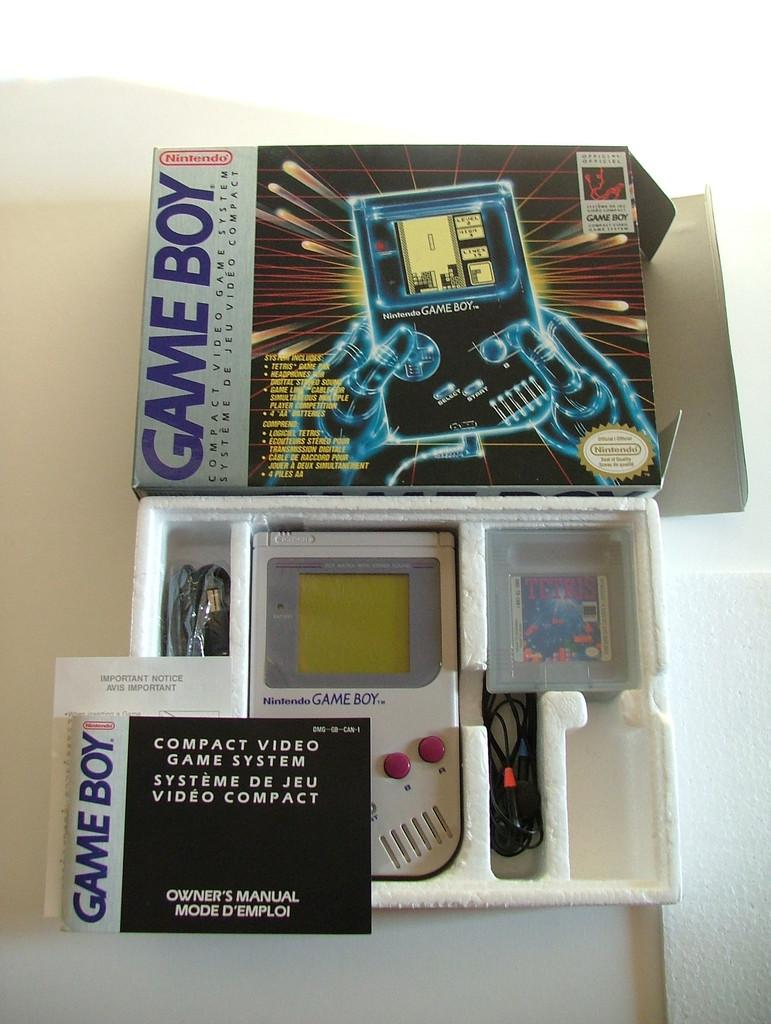<image>
Present a compact description of the photo's key features. A Game Boy video game new in the box with the owner's manual. 